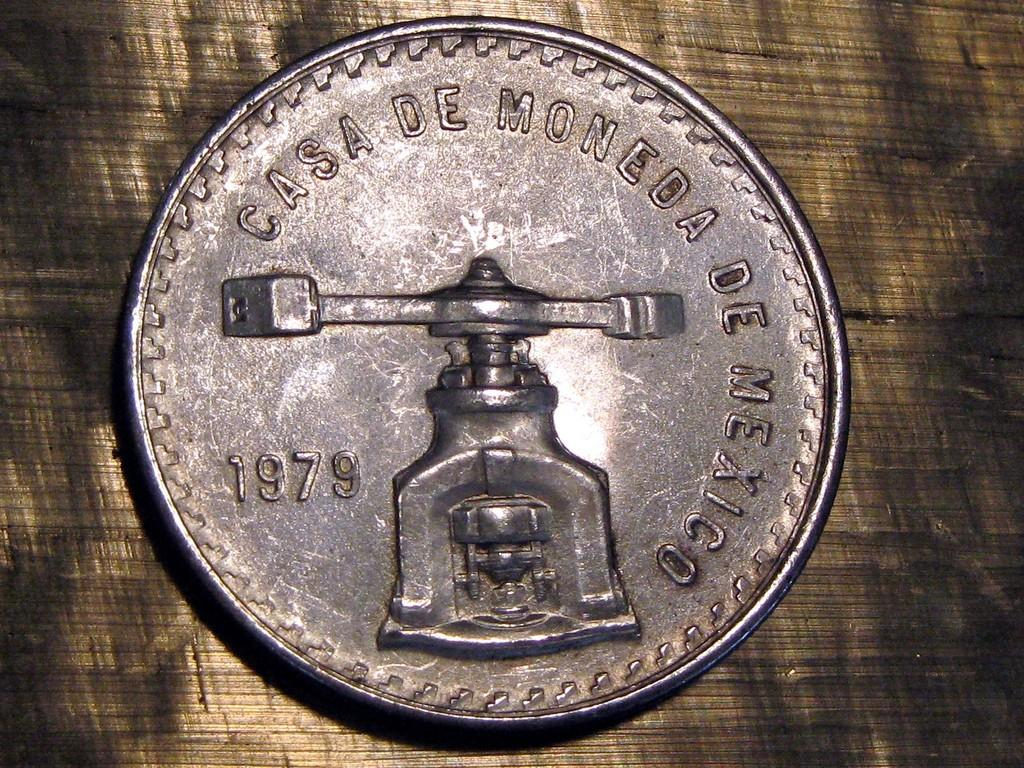Provide a one-sentence caption for the provided image. A silver coin about the size of a quarter. 